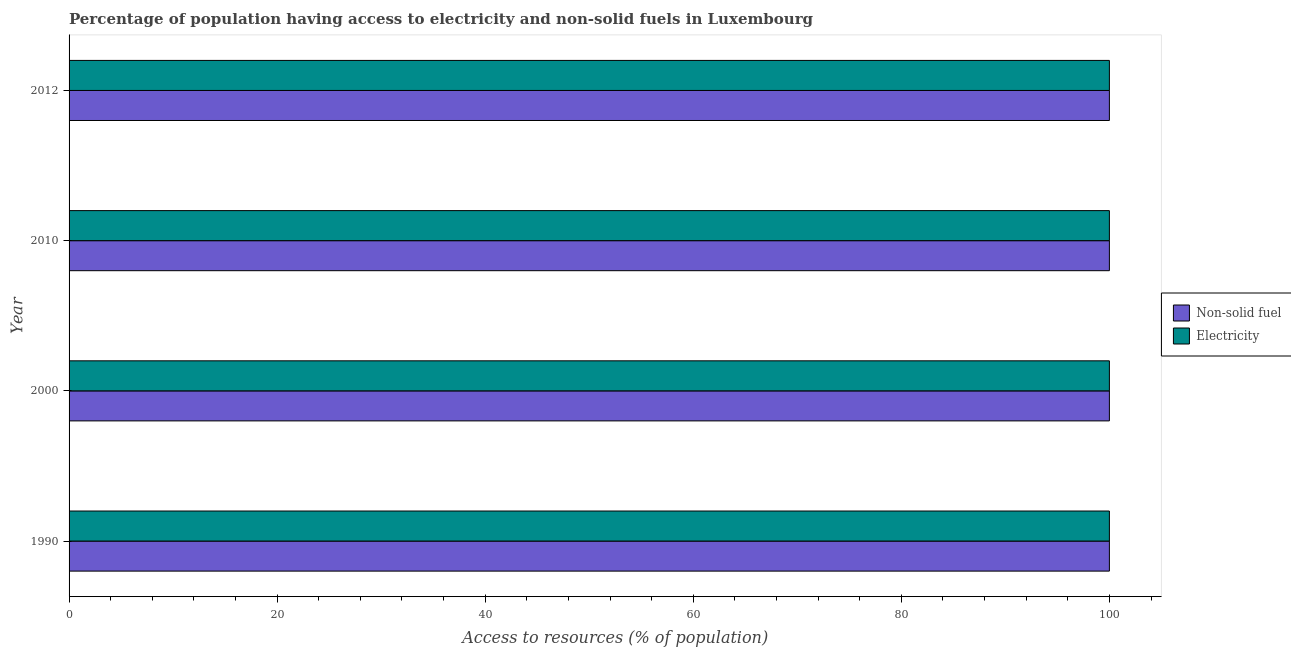How many different coloured bars are there?
Give a very brief answer. 2. How many groups of bars are there?
Your answer should be compact. 4. Are the number of bars on each tick of the Y-axis equal?
Ensure brevity in your answer.  Yes. How many bars are there on the 3rd tick from the top?
Your response must be concise. 2. How many bars are there on the 4th tick from the bottom?
Ensure brevity in your answer.  2. In how many cases, is the number of bars for a given year not equal to the number of legend labels?
Your answer should be compact. 0. What is the percentage of population having access to electricity in 2000?
Make the answer very short. 100. Across all years, what is the maximum percentage of population having access to electricity?
Offer a very short reply. 100. Across all years, what is the minimum percentage of population having access to electricity?
Provide a short and direct response. 100. In which year was the percentage of population having access to electricity maximum?
Offer a very short reply. 1990. In which year was the percentage of population having access to non-solid fuel minimum?
Keep it short and to the point. 1990. What is the total percentage of population having access to electricity in the graph?
Provide a succinct answer. 400. What is the difference between the percentage of population having access to electricity in 1990 and that in 2012?
Make the answer very short. 0. What is the difference between the percentage of population having access to electricity in 2010 and the percentage of population having access to non-solid fuel in 1990?
Make the answer very short. 0. What is the average percentage of population having access to electricity per year?
Your answer should be very brief. 100. In the year 2010, what is the difference between the percentage of population having access to non-solid fuel and percentage of population having access to electricity?
Provide a succinct answer. 0. In how many years, is the percentage of population having access to non-solid fuel greater than 100 %?
Keep it short and to the point. 0. What is the ratio of the percentage of population having access to non-solid fuel in 2000 to that in 2010?
Make the answer very short. 1. What does the 2nd bar from the top in 1990 represents?
Your answer should be very brief. Non-solid fuel. What does the 2nd bar from the bottom in 1990 represents?
Keep it short and to the point. Electricity. How many bars are there?
Ensure brevity in your answer.  8. Does the graph contain any zero values?
Offer a terse response. No. How many legend labels are there?
Keep it short and to the point. 2. How are the legend labels stacked?
Provide a succinct answer. Vertical. What is the title of the graph?
Your answer should be very brief. Percentage of population having access to electricity and non-solid fuels in Luxembourg. What is the label or title of the X-axis?
Provide a succinct answer. Access to resources (% of population). What is the Access to resources (% of population) in Non-solid fuel in 1990?
Your answer should be very brief. 100. What is the Access to resources (% of population) of Electricity in 2000?
Offer a very short reply. 100. What is the Access to resources (% of population) of Electricity in 2010?
Offer a terse response. 100. What is the Access to resources (% of population) of Non-solid fuel in 2012?
Offer a terse response. 100. What is the Access to resources (% of population) in Electricity in 2012?
Your answer should be compact. 100. Across all years, what is the maximum Access to resources (% of population) of Non-solid fuel?
Offer a terse response. 100. Across all years, what is the maximum Access to resources (% of population) in Electricity?
Your response must be concise. 100. What is the total Access to resources (% of population) in Electricity in the graph?
Offer a terse response. 400. What is the difference between the Access to resources (% of population) in Electricity in 1990 and that in 2000?
Provide a short and direct response. 0. What is the difference between the Access to resources (% of population) in Electricity in 1990 and that in 2012?
Your answer should be compact. 0. What is the difference between the Access to resources (% of population) of Non-solid fuel in 2000 and that in 2010?
Ensure brevity in your answer.  0. What is the difference between the Access to resources (% of population) in Non-solid fuel in 2000 and that in 2012?
Your response must be concise. 0. What is the difference between the Access to resources (% of population) in Non-solid fuel in 2010 and that in 2012?
Offer a terse response. 0. What is the difference between the Access to resources (% of population) in Non-solid fuel in 1990 and the Access to resources (% of population) in Electricity in 2000?
Ensure brevity in your answer.  0. What is the difference between the Access to resources (% of population) of Non-solid fuel in 2000 and the Access to resources (% of population) of Electricity in 2012?
Your response must be concise. 0. In the year 2012, what is the difference between the Access to resources (% of population) of Non-solid fuel and Access to resources (% of population) of Electricity?
Ensure brevity in your answer.  0. What is the ratio of the Access to resources (% of population) in Non-solid fuel in 1990 to that in 2000?
Offer a terse response. 1. What is the ratio of the Access to resources (% of population) of Electricity in 1990 to that in 2000?
Offer a very short reply. 1. What is the ratio of the Access to resources (% of population) of Non-solid fuel in 1990 to that in 2010?
Ensure brevity in your answer.  1. What is the ratio of the Access to resources (% of population) in Non-solid fuel in 2000 to that in 2010?
Provide a succinct answer. 1. What is the ratio of the Access to resources (% of population) of Non-solid fuel in 2000 to that in 2012?
Your answer should be compact. 1. What is the ratio of the Access to resources (% of population) of Non-solid fuel in 2010 to that in 2012?
Offer a very short reply. 1. What is the ratio of the Access to resources (% of population) of Electricity in 2010 to that in 2012?
Provide a succinct answer. 1. What is the difference between the highest and the second highest Access to resources (% of population) of Non-solid fuel?
Provide a succinct answer. 0. What is the difference between the highest and the second highest Access to resources (% of population) of Electricity?
Make the answer very short. 0. What is the difference between the highest and the lowest Access to resources (% of population) of Non-solid fuel?
Offer a terse response. 0. 